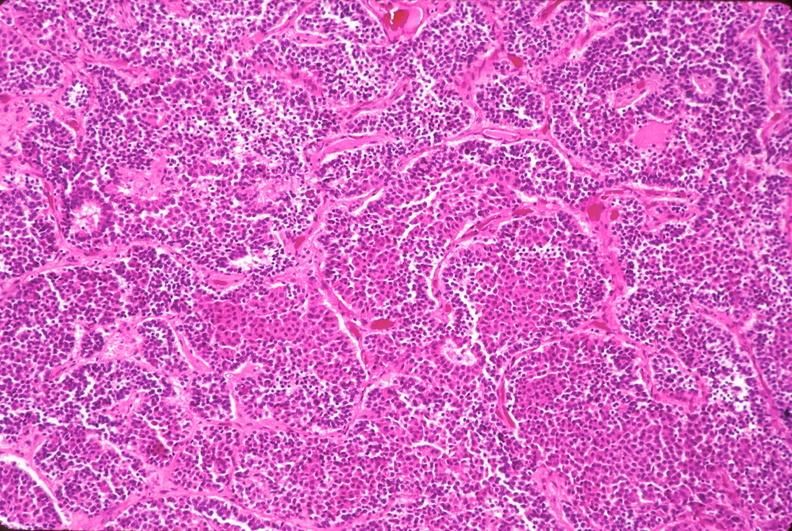where is this part in the figure?
Answer the question using a single word or phrase. Endocrine system 